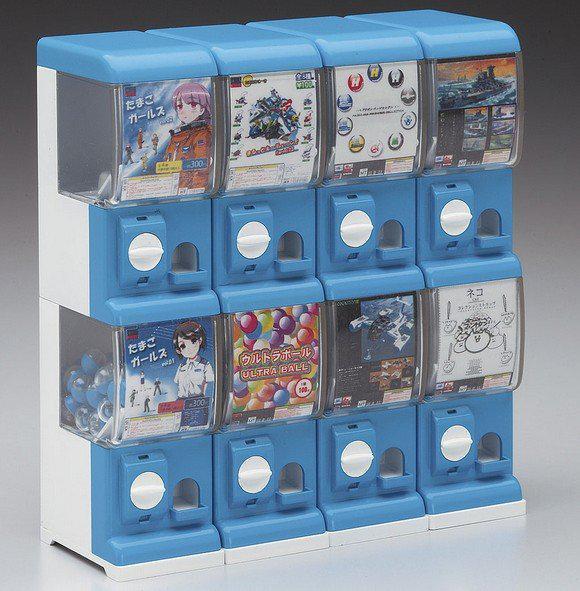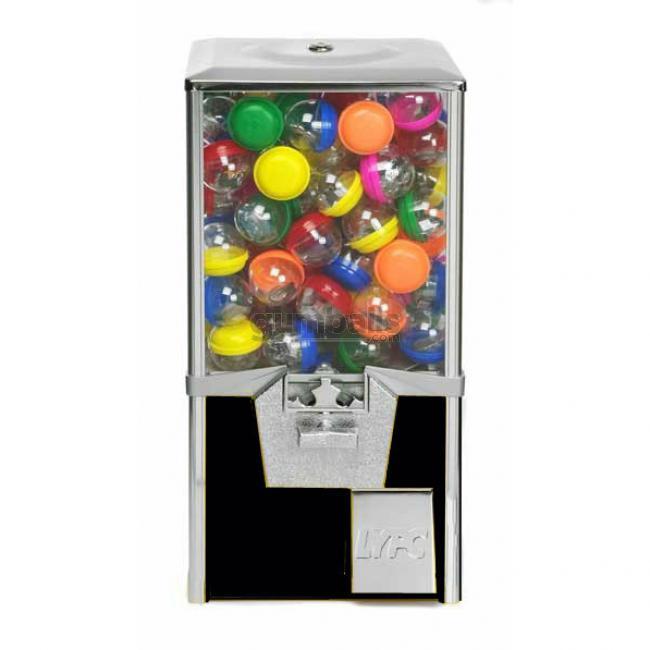The first image is the image on the left, the second image is the image on the right. Evaluate the accuracy of this statement regarding the images: "There are exactly 3 toy vending machines.". Is it true? Answer yes or no. No. 